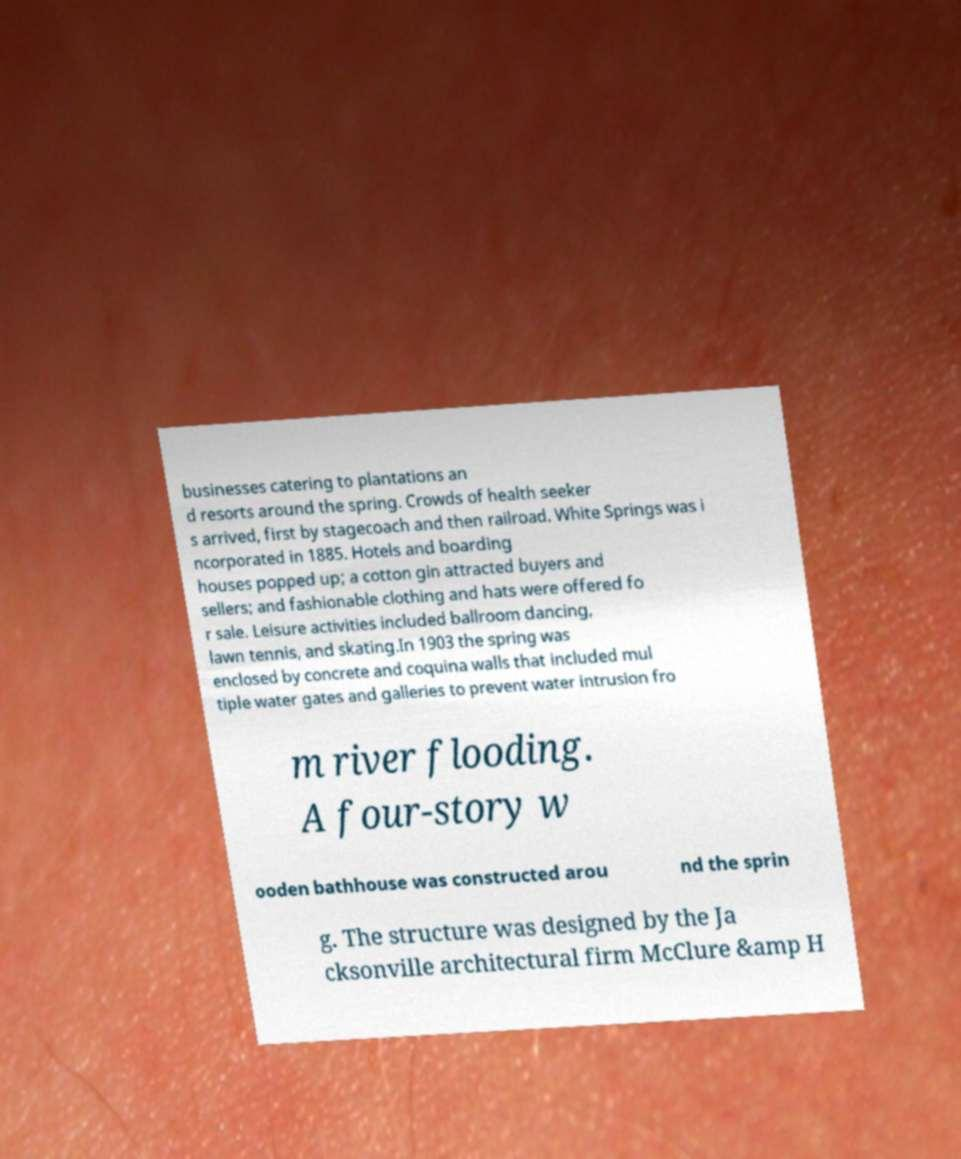For documentation purposes, I need the text within this image transcribed. Could you provide that? businesses catering to plantations an d resorts around the spring. Crowds of health seeker s arrived, first by stagecoach and then railroad. White Springs was i ncorporated in 1885. Hotels and boarding houses popped up; a cotton gin attracted buyers and sellers; and fashionable clothing and hats were offered fo r sale. Leisure activities included ballroom dancing, lawn tennis, and skating.In 1903 the spring was enclosed by concrete and coquina walls that included mul tiple water gates and galleries to prevent water intrusion fro m river flooding. A four-story w ooden bathhouse was constructed arou nd the sprin g. The structure was designed by the Ja cksonville architectural firm McClure &amp H 